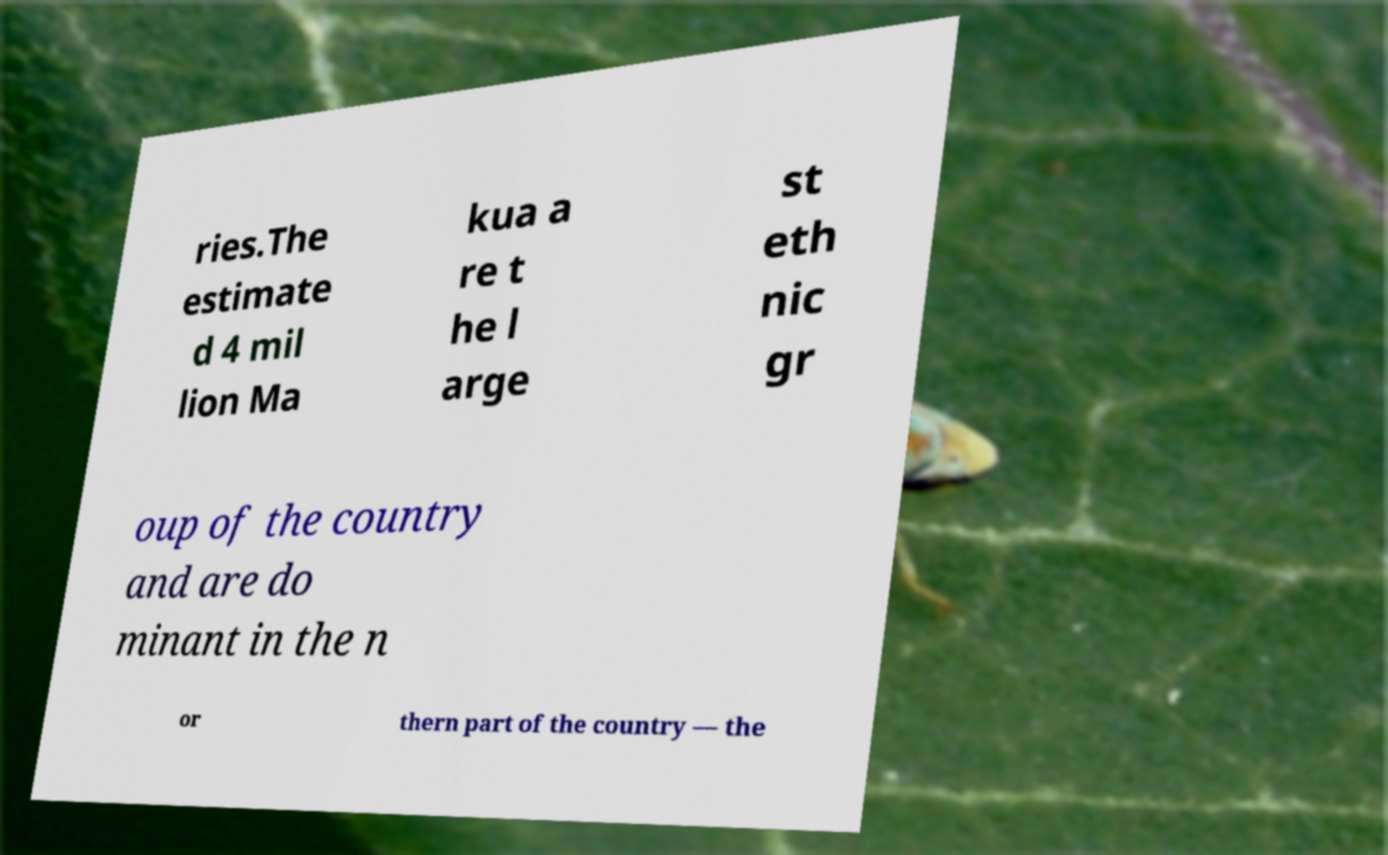I need the written content from this picture converted into text. Can you do that? ries.The estimate d 4 mil lion Ma kua a re t he l arge st eth nic gr oup of the country and are do minant in the n or thern part of the country — the 